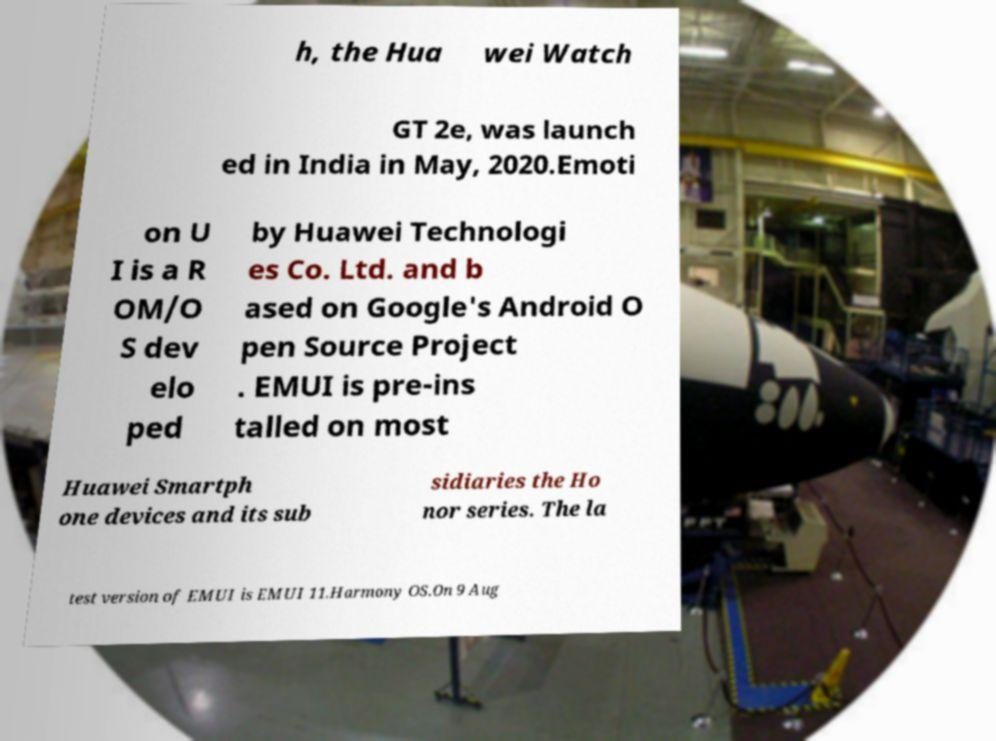Could you extract and type out the text from this image? h, the Hua wei Watch GT 2e, was launch ed in India in May, 2020.Emoti on U I is a R OM/O S dev elo ped by Huawei Technologi es Co. Ltd. and b ased on Google's Android O pen Source Project . EMUI is pre-ins talled on most Huawei Smartph one devices and its sub sidiaries the Ho nor series. The la test version of EMUI is EMUI 11.Harmony OS.On 9 Aug 